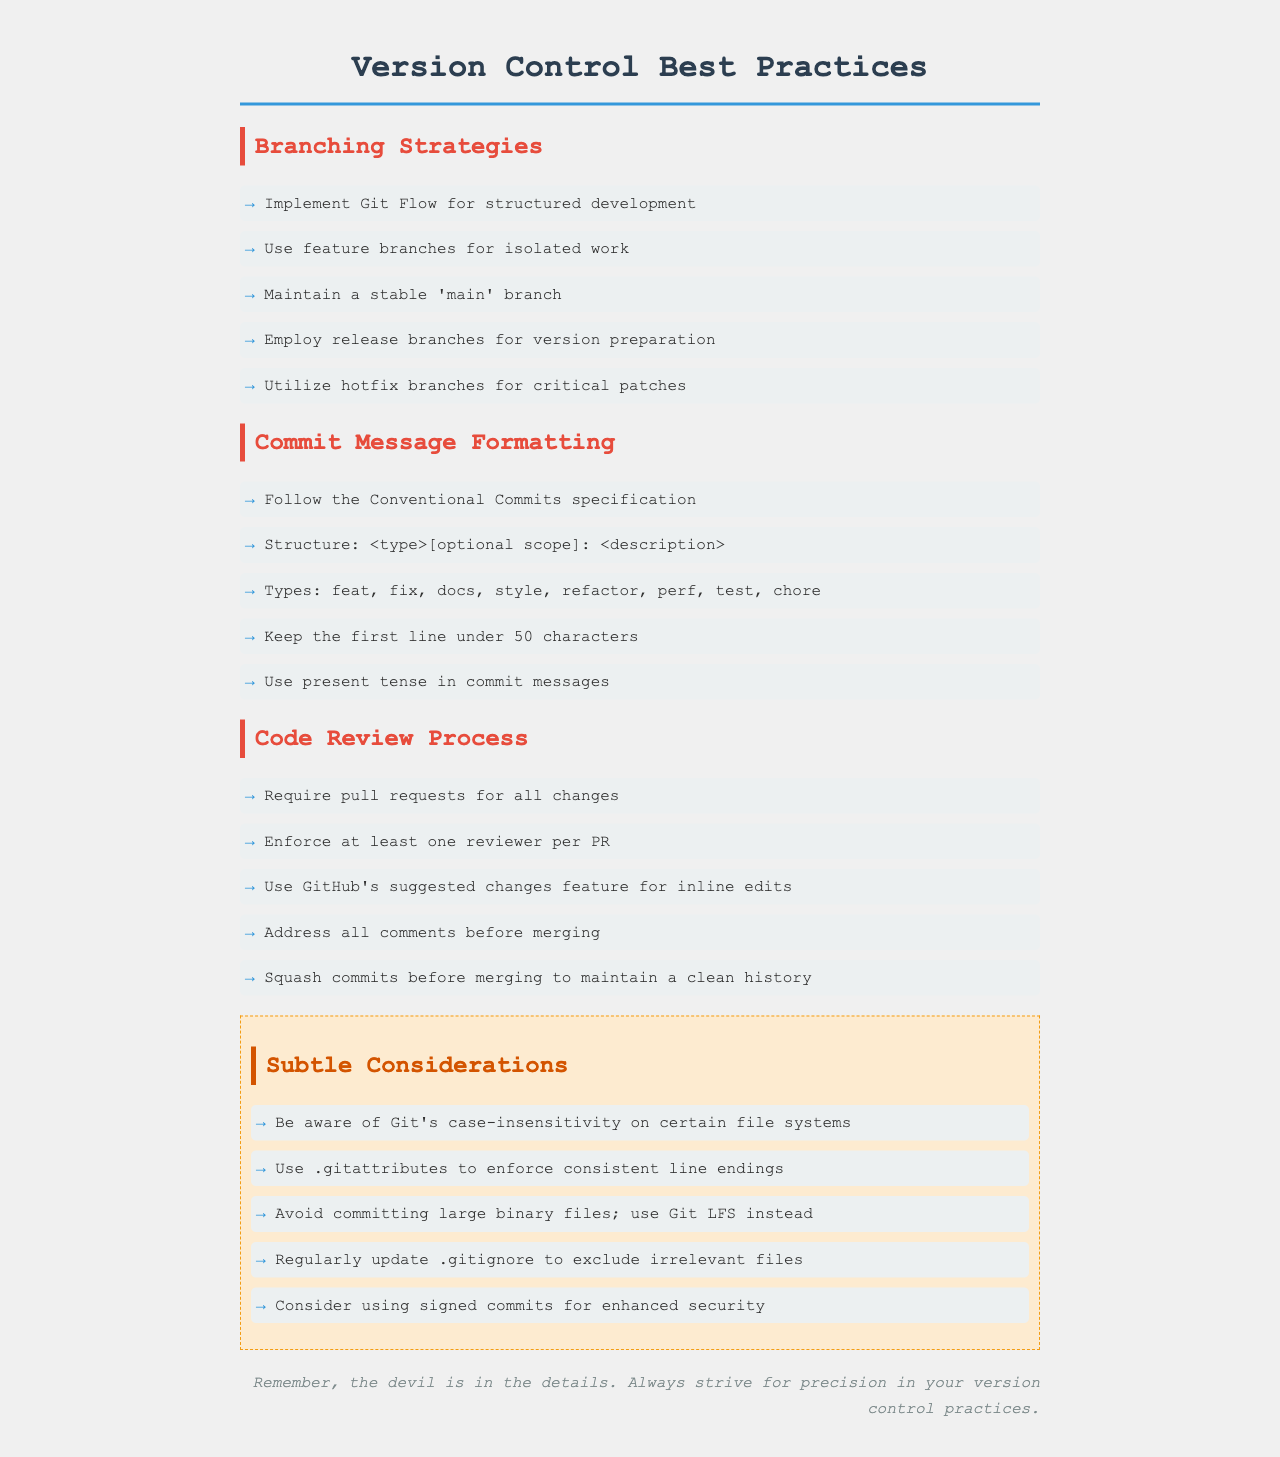What is the main branching strategy recommended? The document recommends using Git Flow for a structured approach to development.
Answer: Git Flow How many types of commit messages are listed? The document lists a total of seven types of commit messages under the 'Types' section.
Answer: seven What should be the maximum length of the first line in a commit message? According to the document, the first line in a commit message should be kept under 50 characters.
Answer: 50 characters What feature should be required for all changes? The document states that pull requests should be required for all changes.
Answer: pull requests What is advised to avoid committing? The document advises avoiding committing large binary files.
Answer: large binary files How many reviewer(s) are required per pull request? The policy document enforces at least one reviewer for each pull request.
Answer: one reviewer What type of branches should be used for critical patches? The document specifies using hotfix branches for critical patches.
Answer: hotfix branches What is a subtle consideration regarding file systems? The document mentions being aware of Git's case-insensitivity on certain file systems.
Answer: case-insensitivity What is recommended for enhancing security in commits? The document recommends considering using signed commits for enhanced security.
Answer: signed commits 